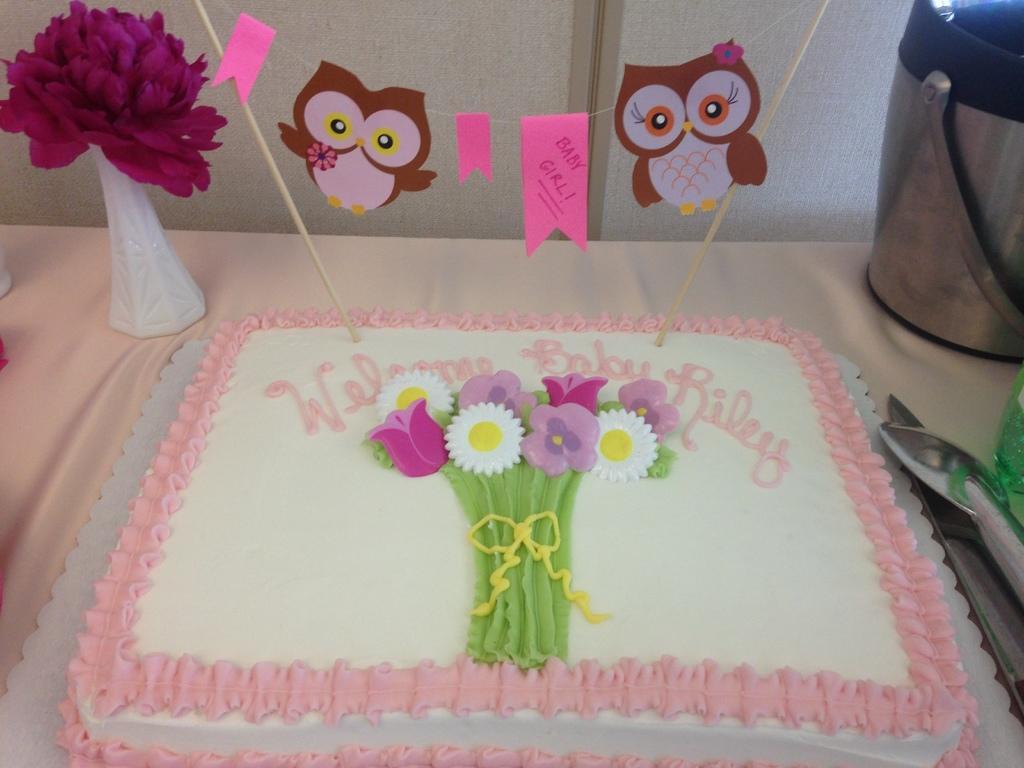Describe this image in one or two sentences. In this picture there is white color cake placed on the table. Behind there is a purple color flower pot and decorative hanging bird. In the background there is a white color wall. 